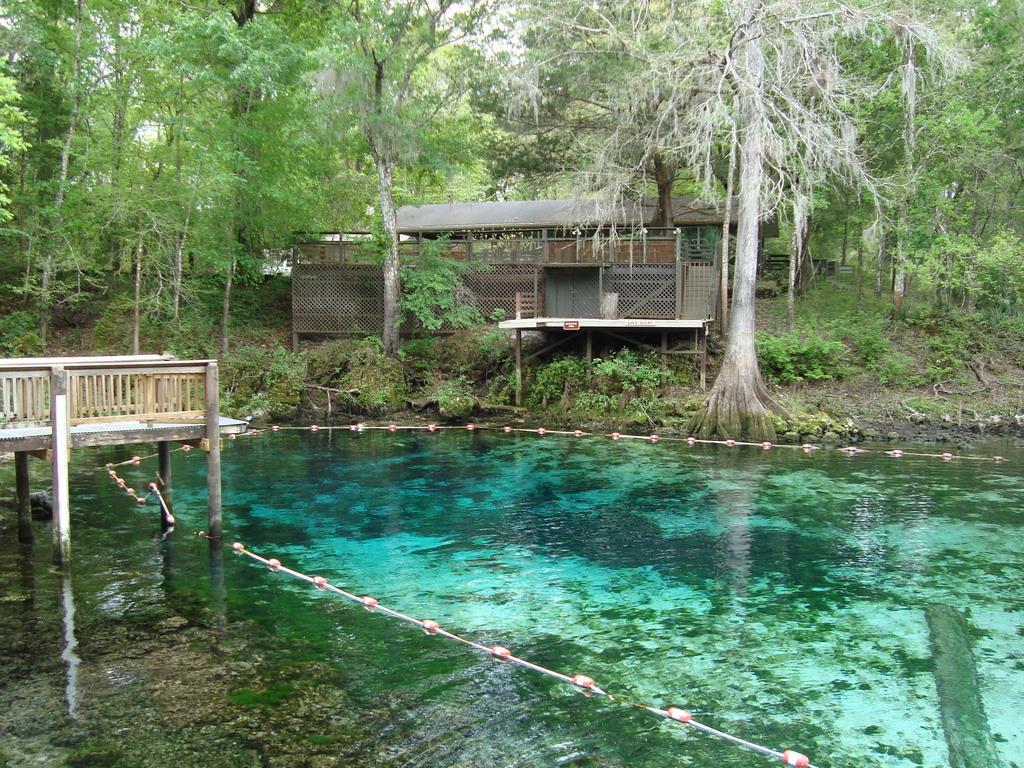In one or two sentences, can you explain what this image depicts? In this picture we can see water, few trees and a house. 